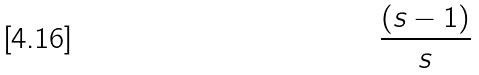<formula> <loc_0><loc_0><loc_500><loc_500>\frac { ( s - 1 ) } { s }</formula> 